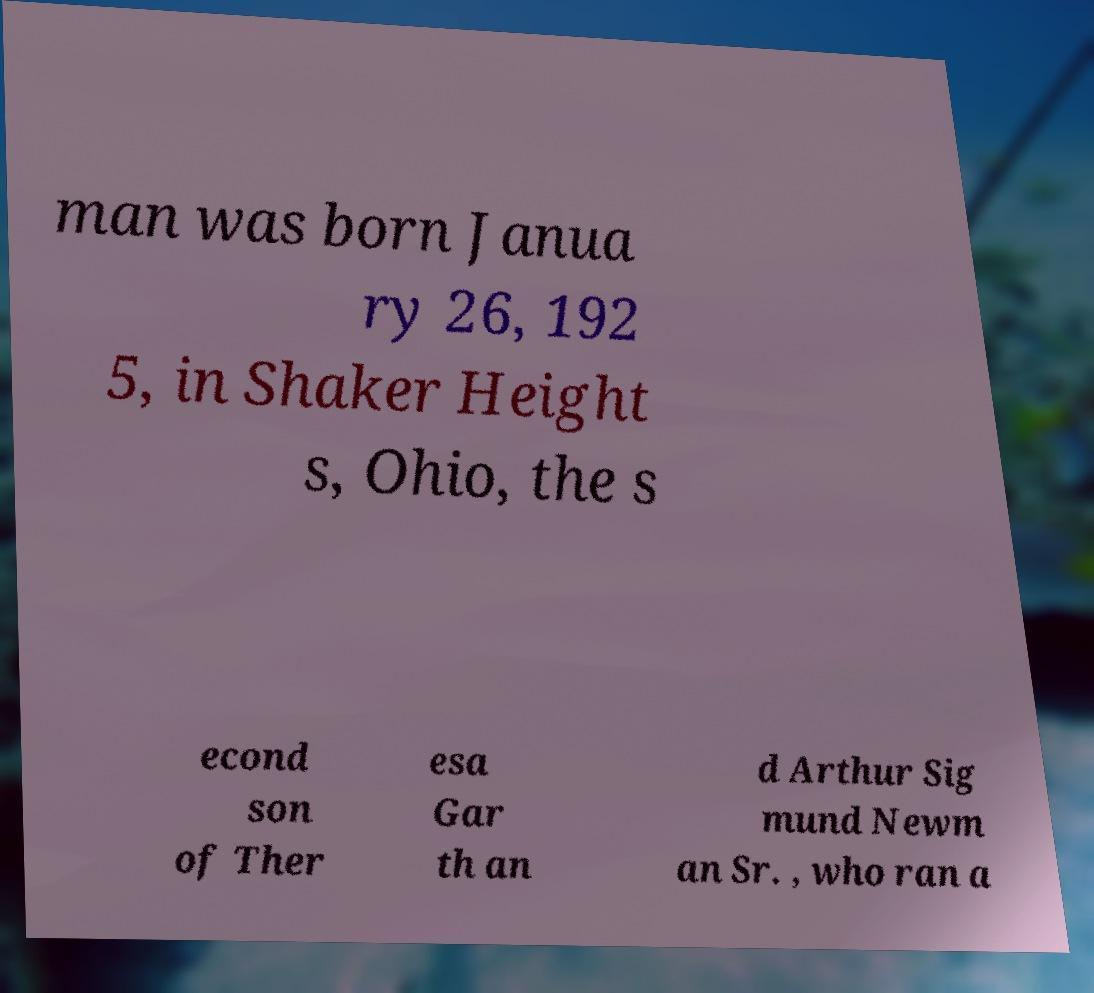Please read and relay the text visible in this image. What does it say? man was born Janua ry 26, 192 5, in Shaker Height s, Ohio, the s econd son of Ther esa Gar th an d Arthur Sig mund Newm an Sr. , who ran a 